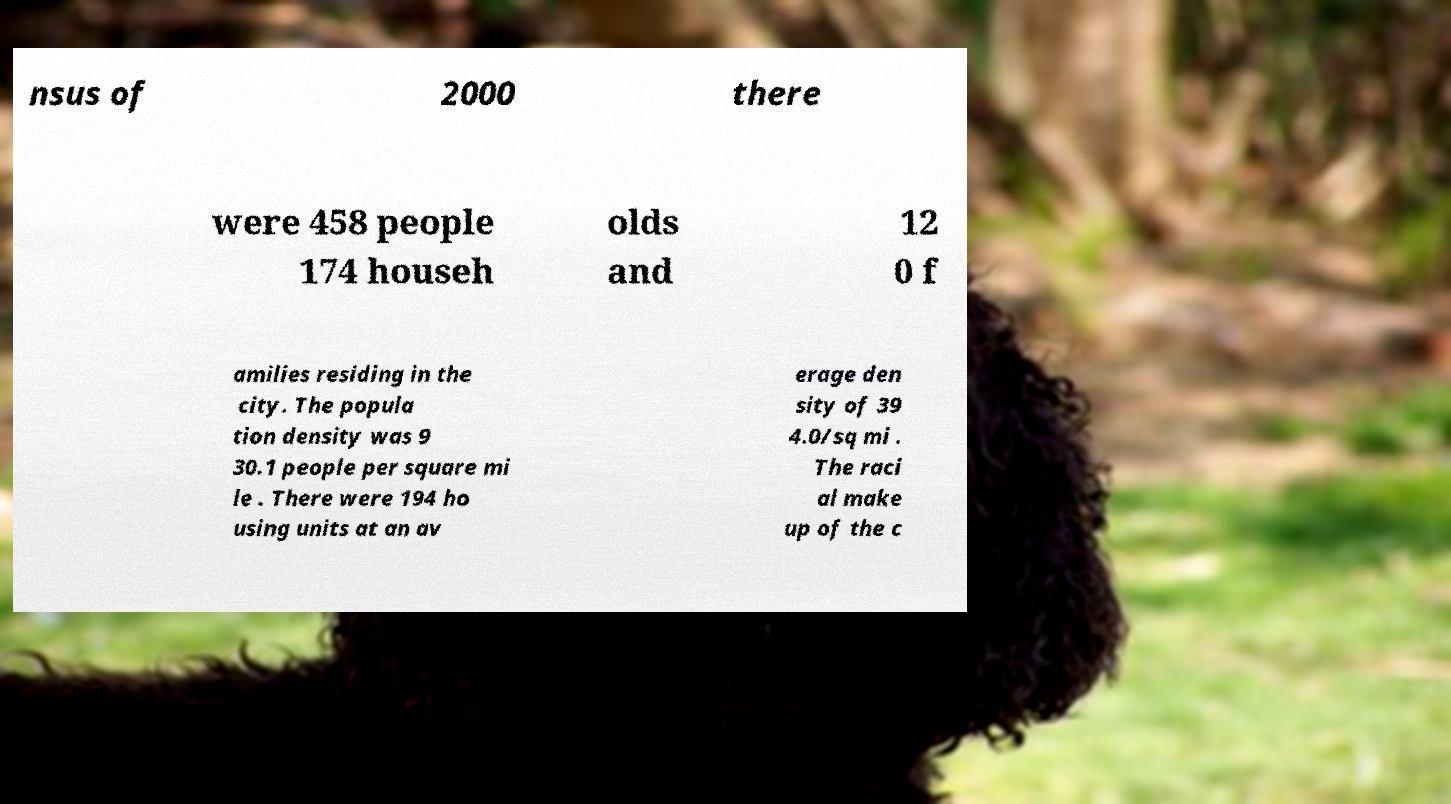What messages or text are displayed in this image? I need them in a readable, typed format. nsus of 2000 there were 458 people 174 househ olds and 12 0 f amilies residing in the city. The popula tion density was 9 30.1 people per square mi le . There were 194 ho using units at an av erage den sity of 39 4.0/sq mi . The raci al make up of the c 